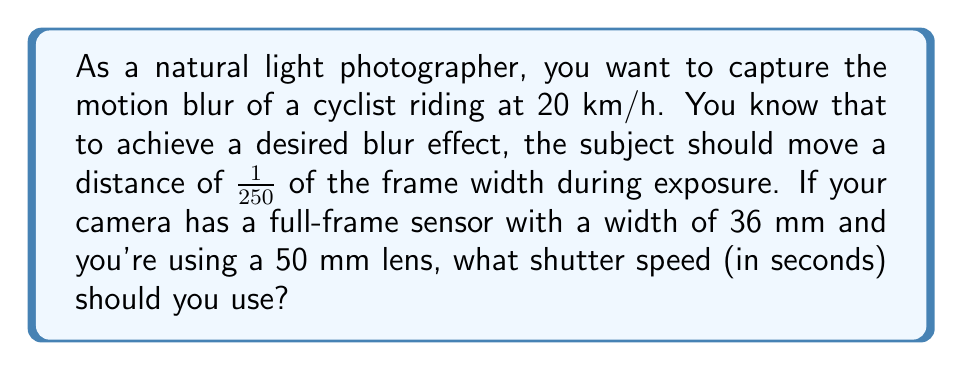Can you solve this math problem? Let's approach this step-by-step:

1) First, we need to calculate the field of view (FOV) width at the subject's distance:
   Let's assume the cyclist is 10 meters away.
   FOV width = $\frac{\text{Sensor width} \times \text{Subject distance}}{\text{Focal length}}$
   $$ \text{FOV width} = \frac{36 \text{ mm} \times 10000 \text{ mm}}{50 \text{ mm}} = 7200 \text{ mm} = 7.2 \text{ m} $$

2) The desired blur is 1/250 of this width:
   $$ \text{Blur distance} = \frac{7.2 \text{ m}}{250} = 0.0288 \text{ m} $$

3) Now, we need to calculate how long it takes the cyclist to travel this distance:
   Speed = 20 km/h = $\frac{20000 \text{ m}}{3600 \text{ s}} = 5.56 \text{ m/s}$
   
   Time = $\frac{\text{Distance}}{\text{Speed}}$
   $$ \text{Time} = \frac{0.0288 \text{ m}}{5.56 \text{ m/s}} = 0.00518 \text{ s} $$

4) This time is the required shutter speed to achieve the desired motion blur.
Answer: 1/193 s 